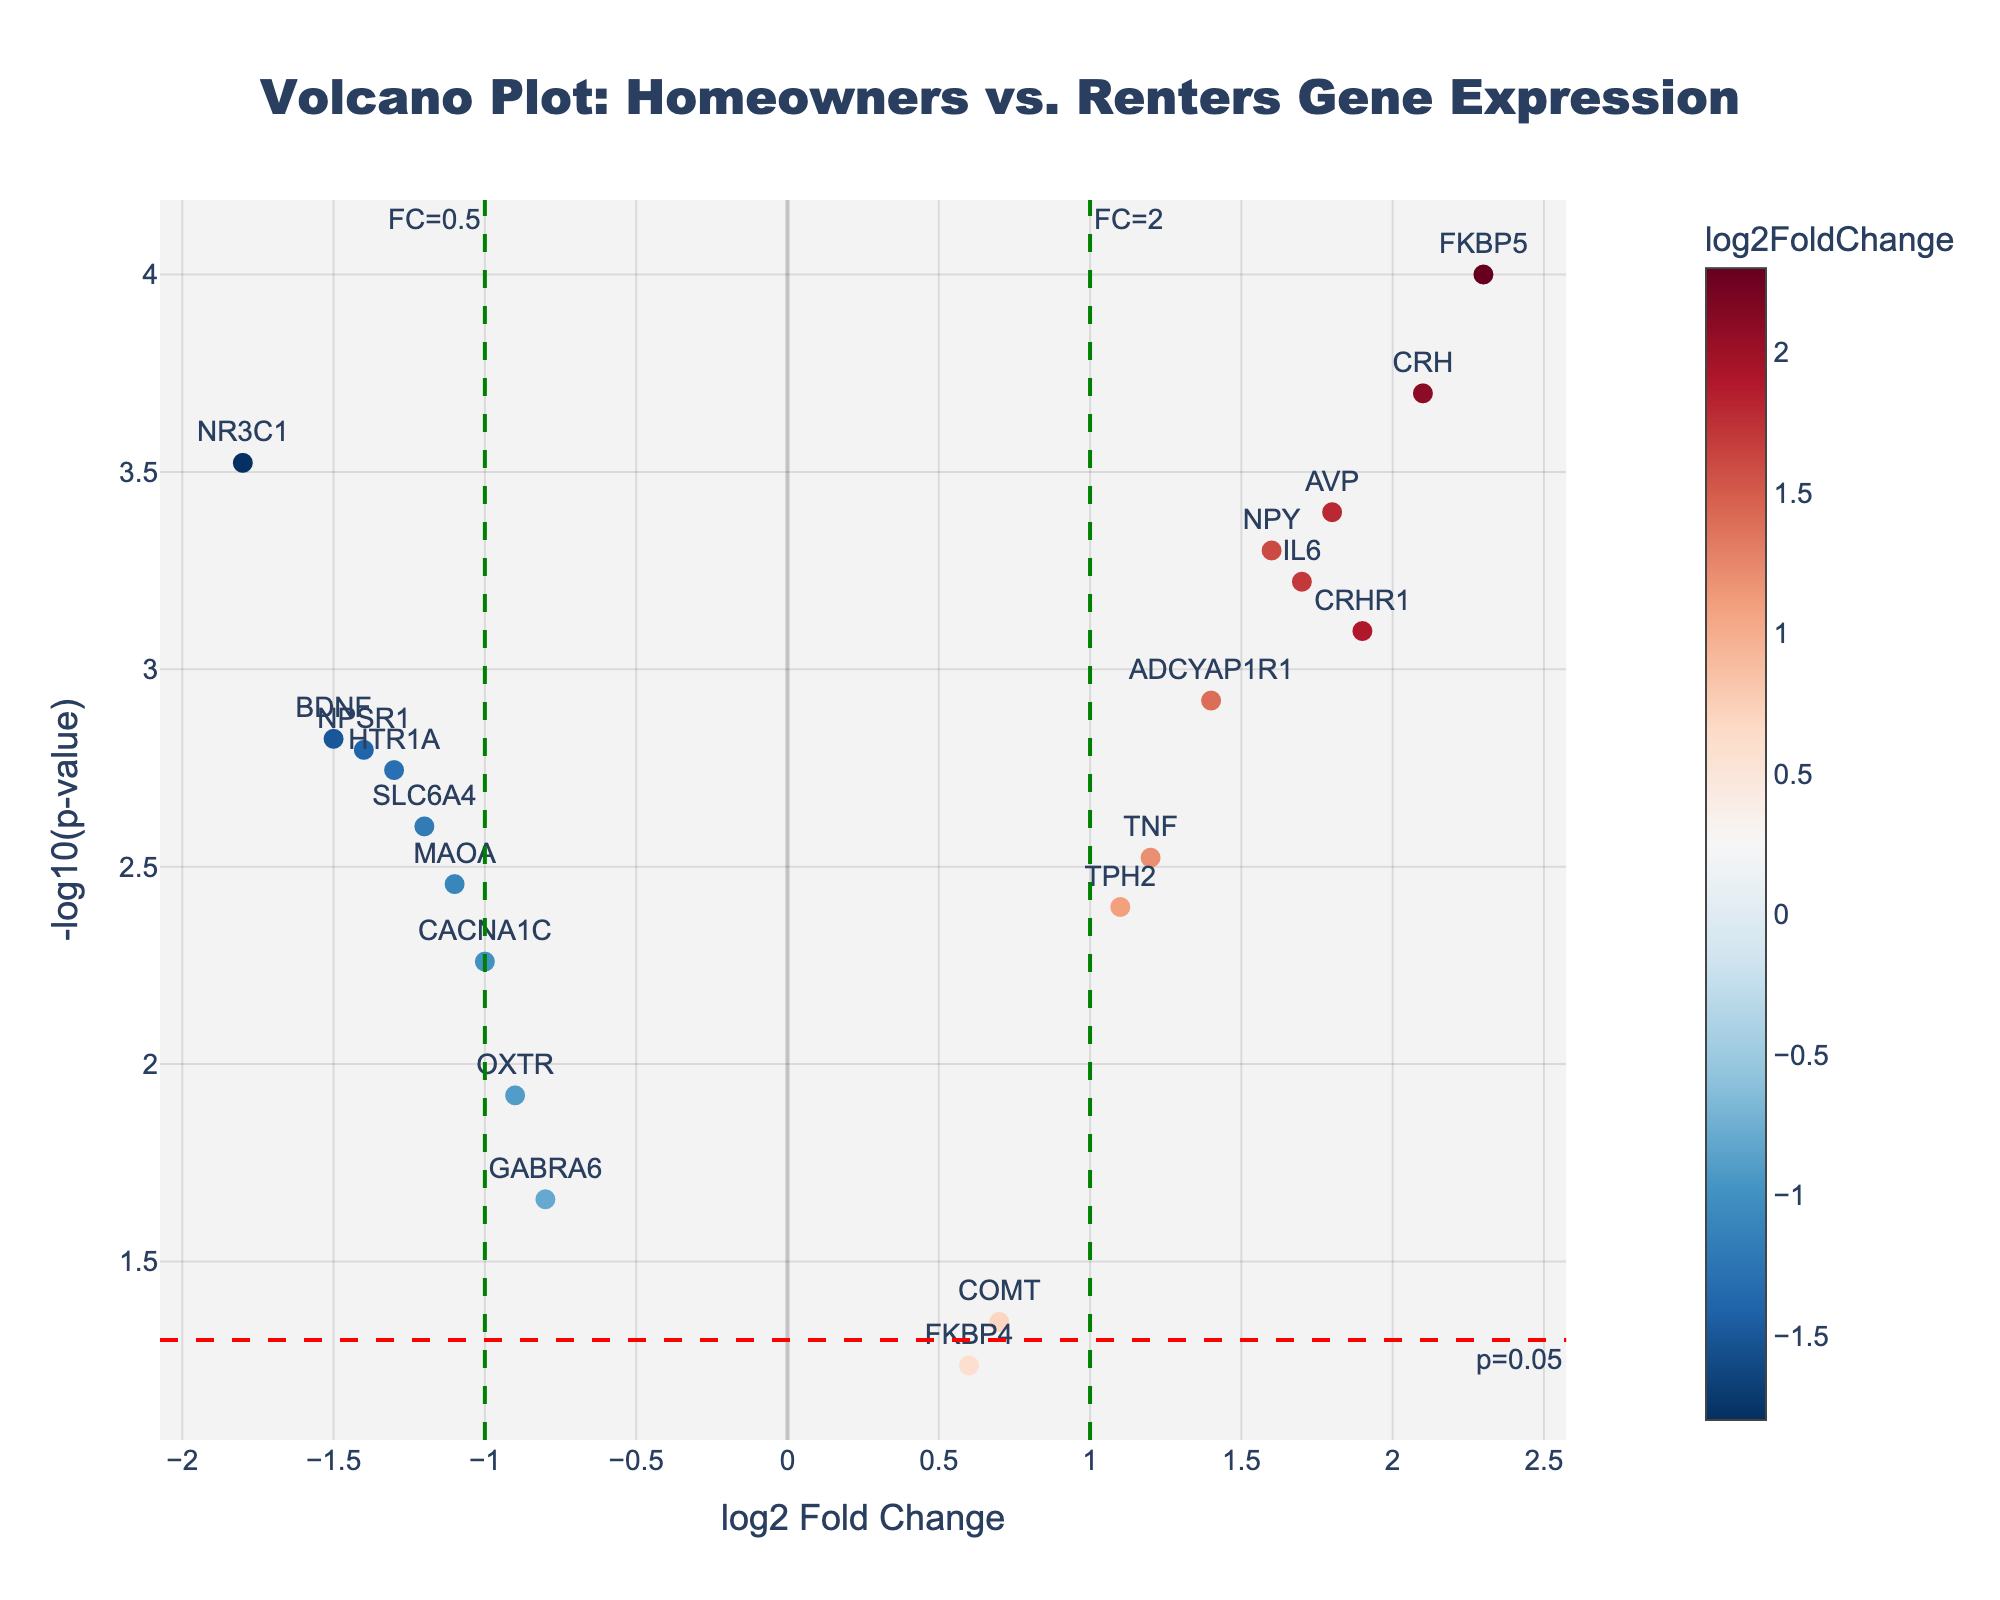How many genes have a positive log2FoldChange? Identify genes with log2FoldChange > 0 from the plot. There are FKBP5, CRHR1, NPY, TPH2, IL6, TNF, CRH, AVP, and ADCYAP1R1. Count them.
Answer: 9 Which gene has the highest -log10(p-value)? Look for the point with the highest y-axis value. The highest point corresponds to FKBP5.
Answer: FKBP5 What threshold is used for significance in terms of p-value? Refer to the horizontal threshold line indicated in the plot's annotation. It is labeled as "p=0.05".
Answer: p=0.05 Which genes have a log2FoldChange less than -1 and are significant? Identify points with log2FoldChange < -1 and -log10(p-value) > -log10(0.05). These genes are NR3C1, BDNF, HTR1A, MAOA, and NPSR1.
Answer: NR3C1, BDNF, HTR1A, MAOA, NPSR1 What is the log2FoldChange of the gene CRH? Identify the position of CRH on the x-axis. The value is 2.1.
Answer: 2.1 Which gene has the smallest log2FoldChange among those that are significant? Among significant genes (those above the p-value threshold line), identify the gene with the smallest log2FoldChange. This is GABRA6 with a log2FoldChange of -0.8.
Answer: GABRA6 Are there more genes upregulated (positive log2FoldChange) or downregulated (negative log2FoldChange)? Count the number of genes with positive log2FoldChange (9) and negative log2FoldChange (10).
Answer: Downregulated Which gene has the closest log2FoldChange to zero but is still significant? Among significant genes, find the gene with log2FoldChange closest to zero. This is COMT with a log2FoldChange of 0.7.
Answer: COMT How many genes are above the significance threshold line? Count the total number of points above the horizontal line marking the p-value threshold. There are 18 genes above the line.
Answer: 18 